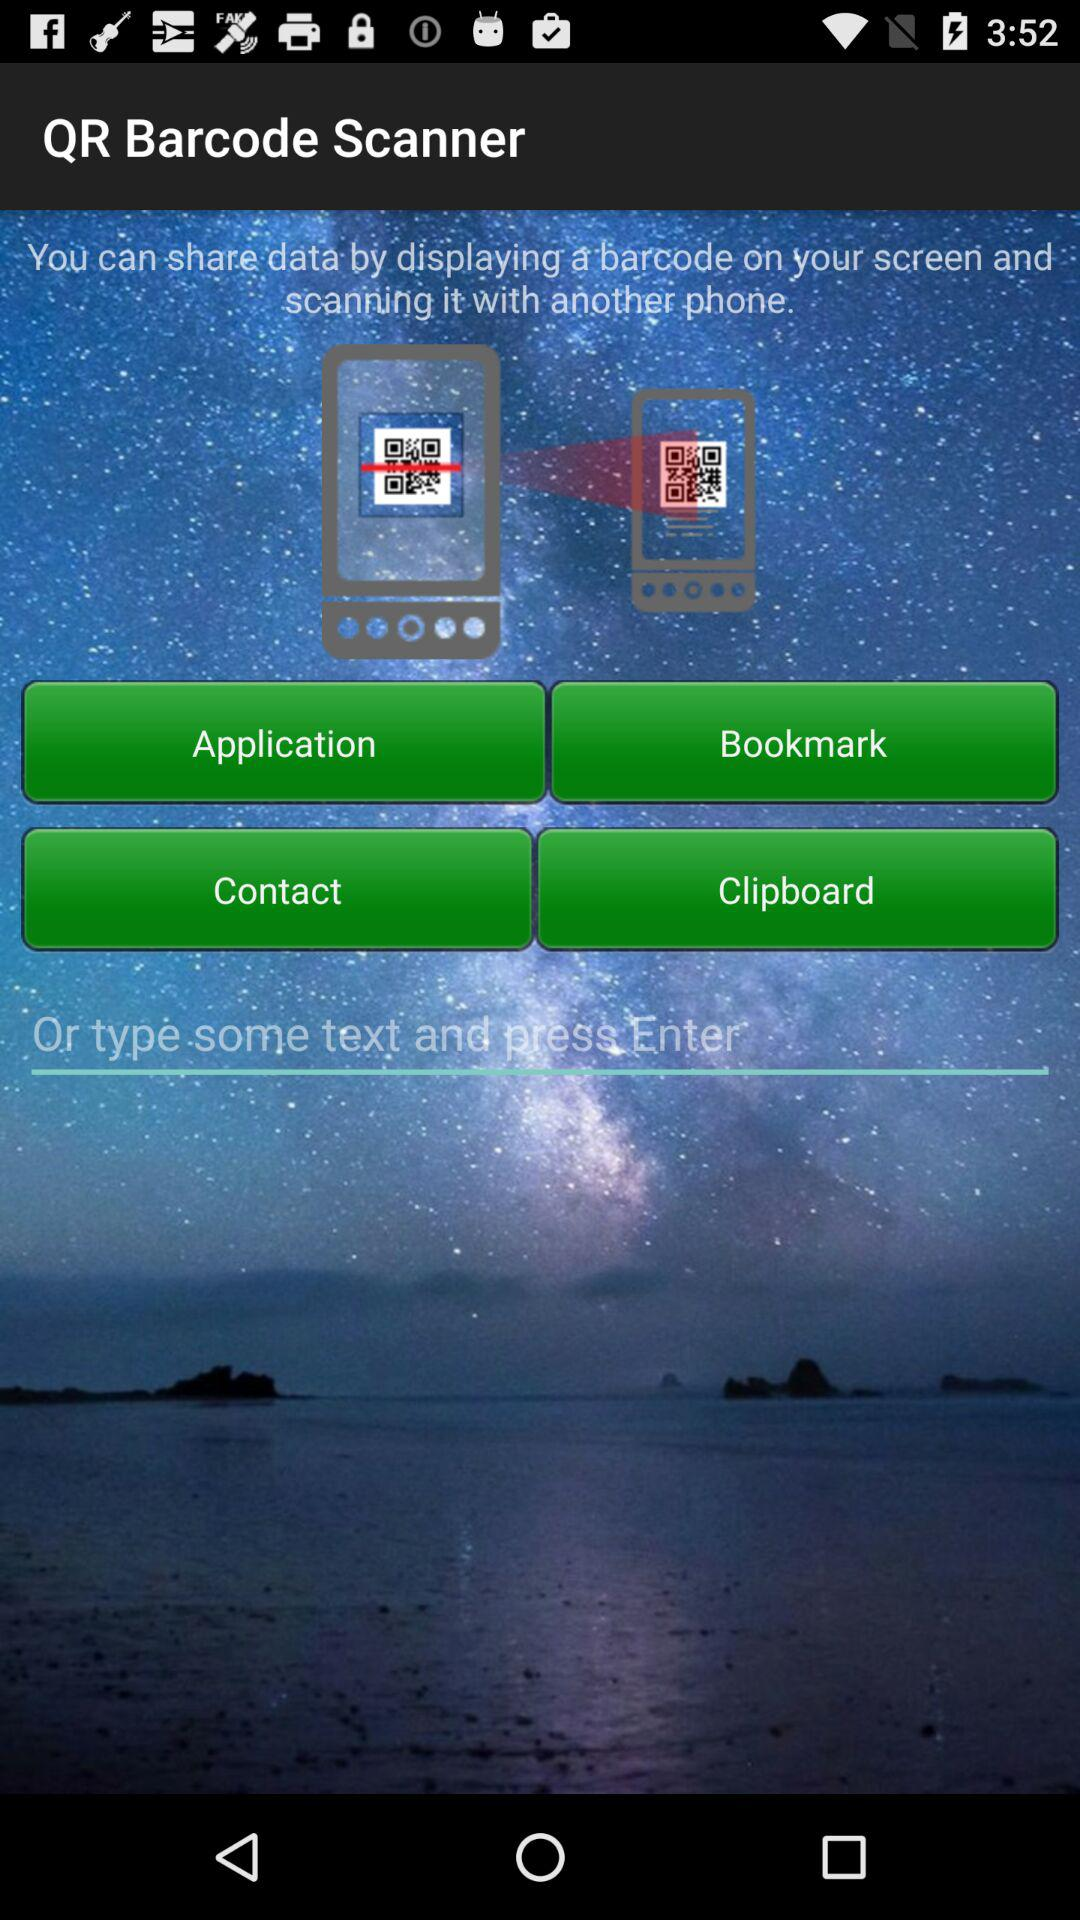What is the name of the application? The name of the application is "QR Barcode Scanner". 